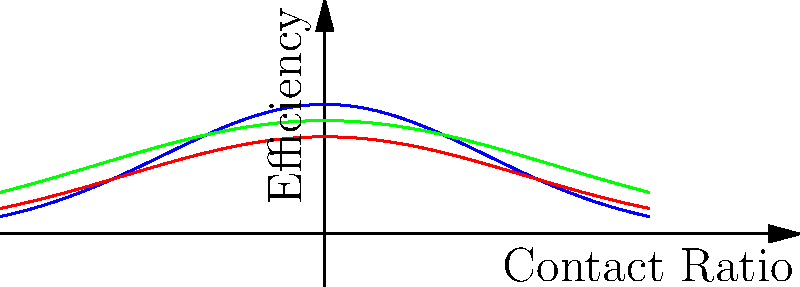As a trial lawyer presenting a case involving mechanical engineering, you need to explain the efficiency of various gear tooth profiles in power transmission. Based on the graph shown, which gear tooth profile would you argue is most efficient for high-speed applications, and why? To answer this question, we need to analyze the graph and understand the characteristics of each gear tooth profile:

1. The graph shows three curves representing different gear tooth profiles: Involute (blue), Cycloidal (red), and Circular Arc (green).

2. The x-axis represents the contact ratio, which is related to the engagement of gear teeth during rotation. A higher contact ratio generally means smoother operation and load distribution.

3. The y-axis represents efficiency, with higher values indicating better performance.

4. For high-speed applications, we want a profile that maintains high efficiency across a wide range of contact ratios.

5. Analyzing the curves:
   - Involute (blue): Has the highest peak efficiency and maintains high efficiency across a wide range of contact ratios.
   - Cycloidal (red): Has a lower peak efficiency and drops off more quickly as contact ratio increases.
   - Circular Arc (green): Has a moderate peak efficiency but maintains it over a narrower range of contact ratios compared to the involute profile.

6. The involute profile (blue) shows the best overall performance, with the highest peak efficiency and the most consistent efficiency across different contact ratios.

7. In high-speed applications, maintaining efficiency is crucial to minimize power losses and heat generation. The involute profile's ability to maintain high efficiency across various contact ratios makes it ideal for such applications.

Therefore, as a trial lawyer, you would argue that the involute gear tooth profile is most efficient for high-speed applications due to its superior performance characteristics shown in the graph.
Answer: Involute profile, due to highest peak efficiency and consistent performance across contact ratios. 